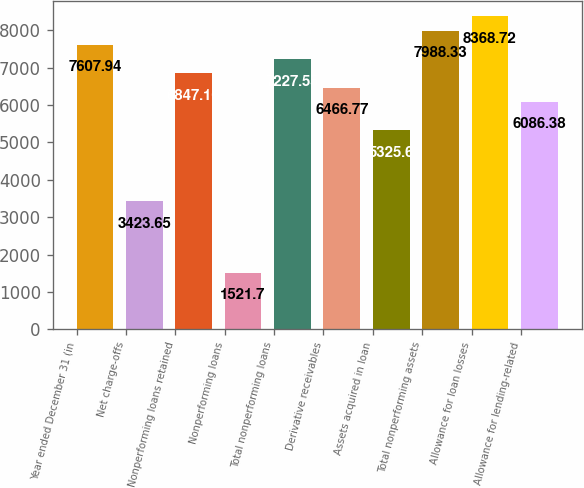Convert chart. <chart><loc_0><loc_0><loc_500><loc_500><bar_chart><fcel>Year ended December 31 (in<fcel>Net charge-offs<fcel>Nonperforming loans retained<fcel>Nonperforming loans<fcel>Total nonperforming loans<fcel>Derivative receivables<fcel>Assets acquired in loan<fcel>Total nonperforming assets<fcel>Allowance for loan losses<fcel>Allowance for lending-related<nl><fcel>7607.94<fcel>3423.65<fcel>6847.16<fcel>1521.7<fcel>7227.55<fcel>6466.77<fcel>5325.6<fcel>7988.33<fcel>8368.72<fcel>6086.38<nl></chart> 